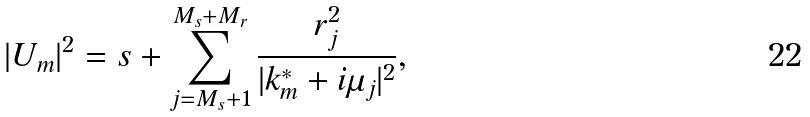Convert formula to latex. <formula><loc_0><loc_0><loc_500><loc_500>| U _ { m } | ^ { 2 } = s + \sum _ { j = M _ { s } + 1 } ^ { M _ { s } + M _ { r } } \frac { r _ { j } ^ { 2 } } { | k _ { m } ^ { \ast } + i \mu _ { j } | ^ { 2 } } ,</formula> 